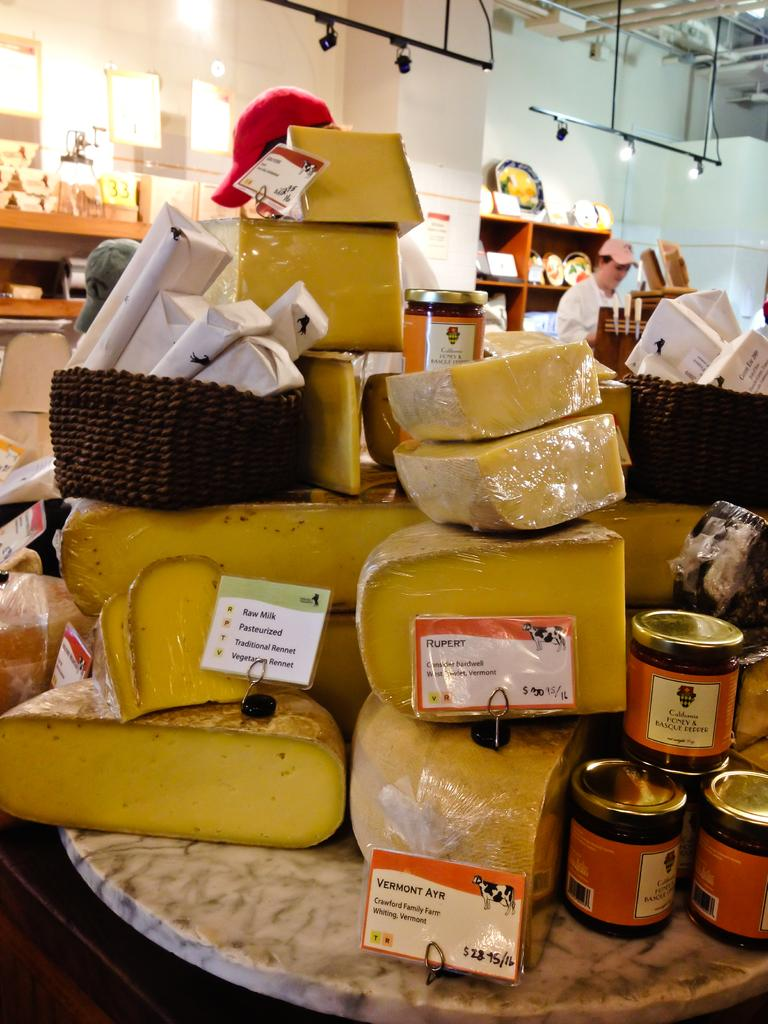What type of objects can be seen in the image? There are boxes, bottles, shelves, and plates in the image. What is the purpose of the shelves in the image? The shelves are likely used for storage or displaying the items in the image. What can be seen on the wall in the image? There is a man standing in the image. What is the man doing in the image? The man is standing in the image, but his specific actions or purpose cannot be determined from the provided facts. How many fans are visible on the man's fingers in the image? There are no fans or fingers visible on the man in the image. 